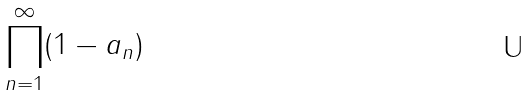<formula> <loc_0><loc_0><loc_500><loc_500>\prod _ { n = 1 } ^ { \infty } ( 1 - a _ { n } )</formula> 